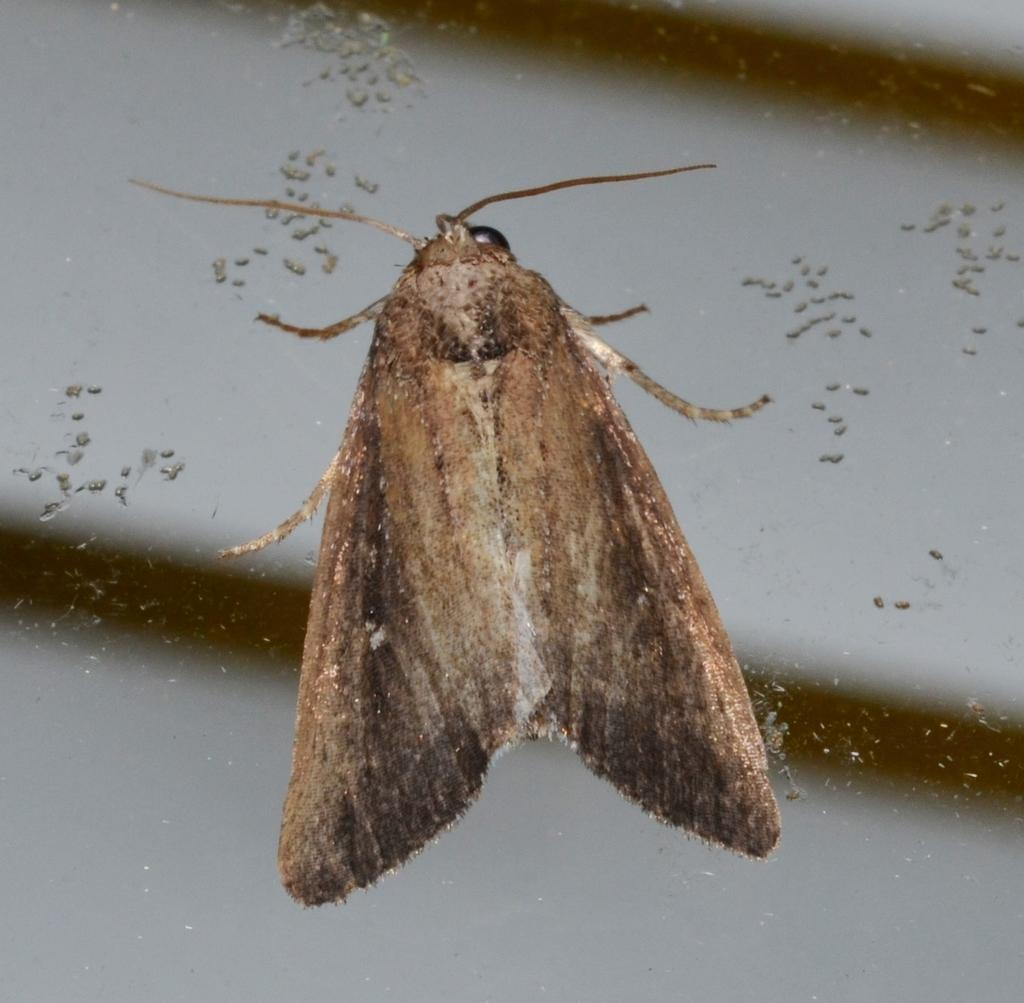What type of insect is in the image? There is a moth in the image. What is the moth standing on? The moth is standing on a glass wall. What type of organization is depicted in the image? There is no organization depicted in the image; it features a moth standing on a glass wall. How does the cow interact with the moth in the image? There is no cow present in the image, so it cannot interact with the moth. 